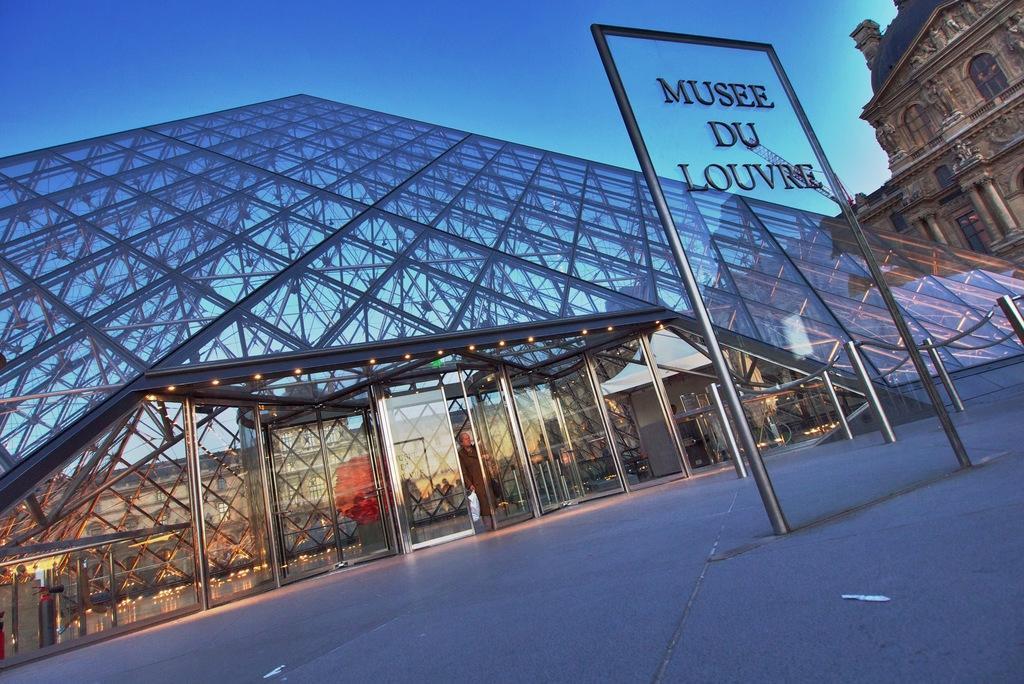Could you give a brief overview of what you see in this image? In front of the image there is a glass board with name on it, around the glass there is metal rods, behind that there is a building with glass supported by metal rods, in front of the building there is a person, above the person there are lights, on the top right of the image there is another building. 